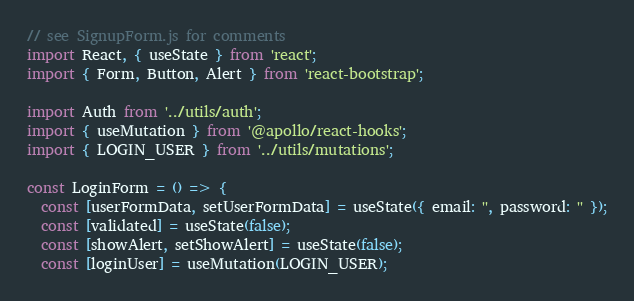Convert code to text. <code><loc_0><loc_0><loc_500><loc_500><_JavaScript_>// see SignupForm.js for comments
import React, { useState } from 'react';
import { Form, Button, Alert } from 'react-bootstrap';

import Auth from '../utils/auth';
import { useMutation } from '@apollo/react-hooks';
import { LOGIN_USER } from '../utils/mutations';

const LoginForm = () => {
  const [userFormData, setUserFormData] = useState({ email: '', password: '' });
  const [validated] = useState(false);
  const [showAlert, setShowAlert] = useState(false);
  const [loginUser] = useMutation(LOGIN_USER);
</code> 